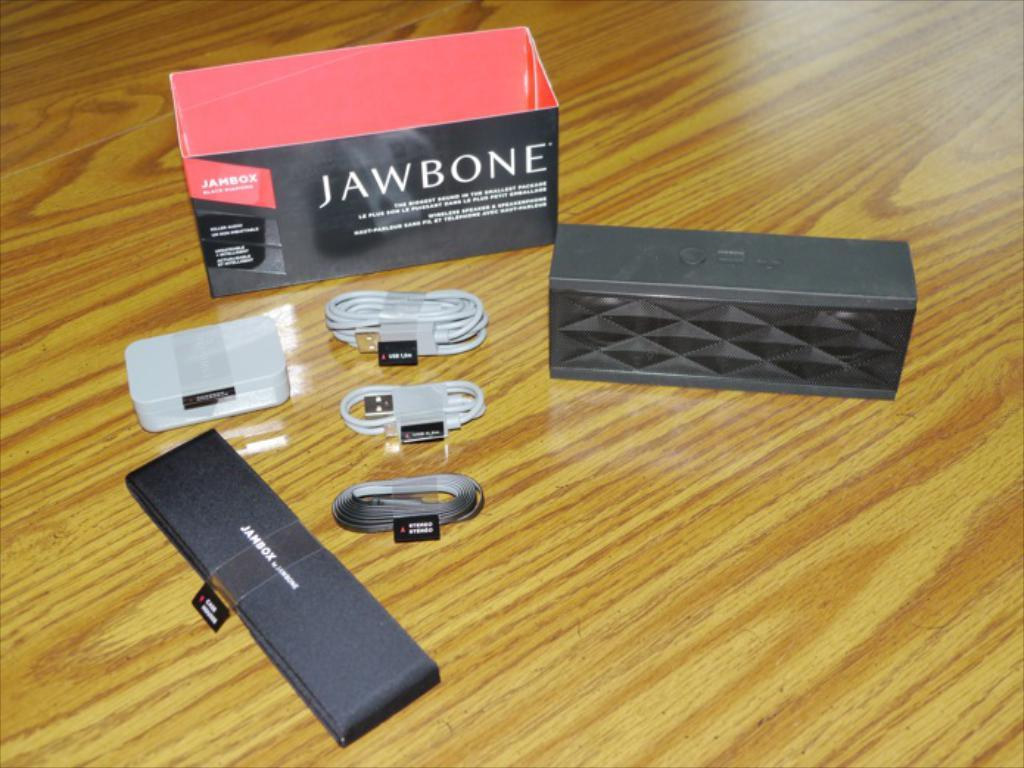<image>
Share a concise interpretation of the image provided. A Jawbone box sits behind a set of cords. 